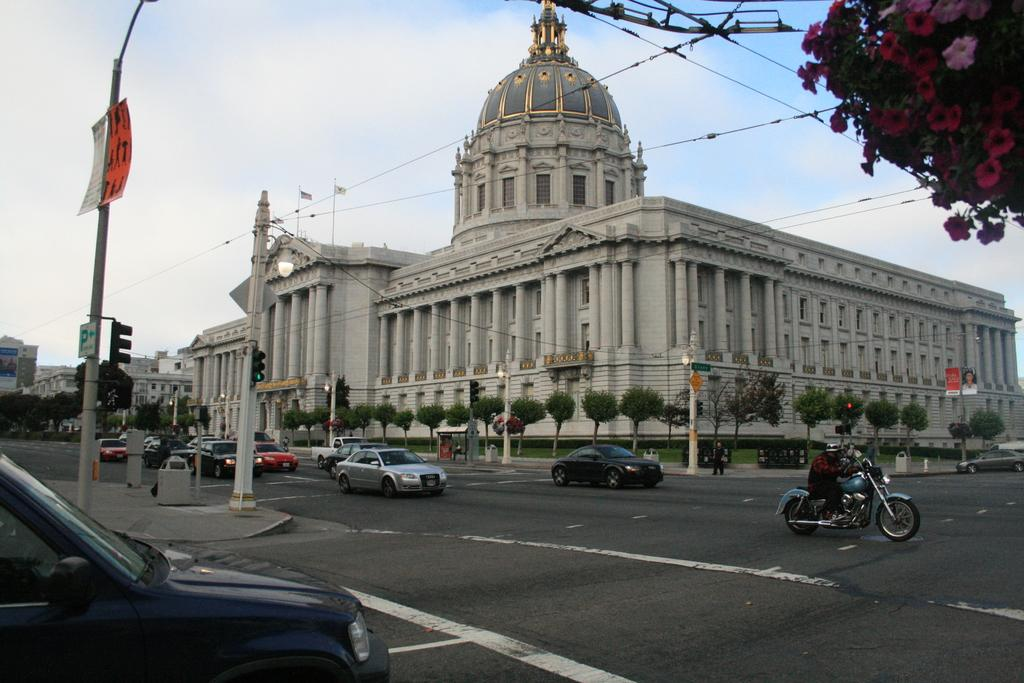What type of structures can be seen in the image? There are buildings in the image. What features do the buildings have? The buildings have windows. What natural elements are present in the image? There are trees in the image. What traffic control devices are visible in the image? Traffic signals are present in the image. What vertical structures can be seen in the image? Poles are visible in the image. What type of signage is present in the image? Boards are present in the image. What national symbols are visible in the image? Flags are visible in the image. What type of lighting infrastructure is present in the image? Light poles are present in the image. What mode of transportation can be seen in the image? Vehicles are on the road in the image. What is the color of the sky in the image? The sky is blue and white in color. What is the tendency of the spoon to move in the image? There is no spoon present in the image, so it is not possible to determine its tendency to move. How does the wilderness contribute to the image? There is no wilderness present in the image; it features urban elements such as buildings, trees, and vehicles. 